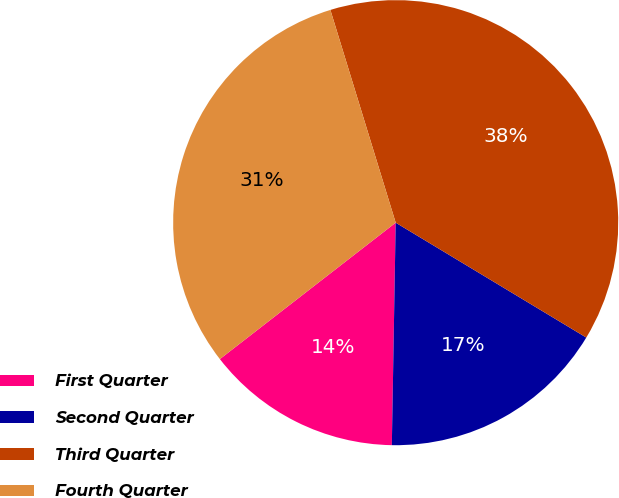Convert chart to OTSL. <chart><loc_0><loc_0><loc_500><loc_500><pie_chart><fcel>First Quarter<fcel>Second Quarter<fcel>Third Quarter<fcel>Fourth Quarter<nl><fcel>14.22%<fcel>16.64%<fcel>38.37%<fcel>30.76%<nl></chart> 